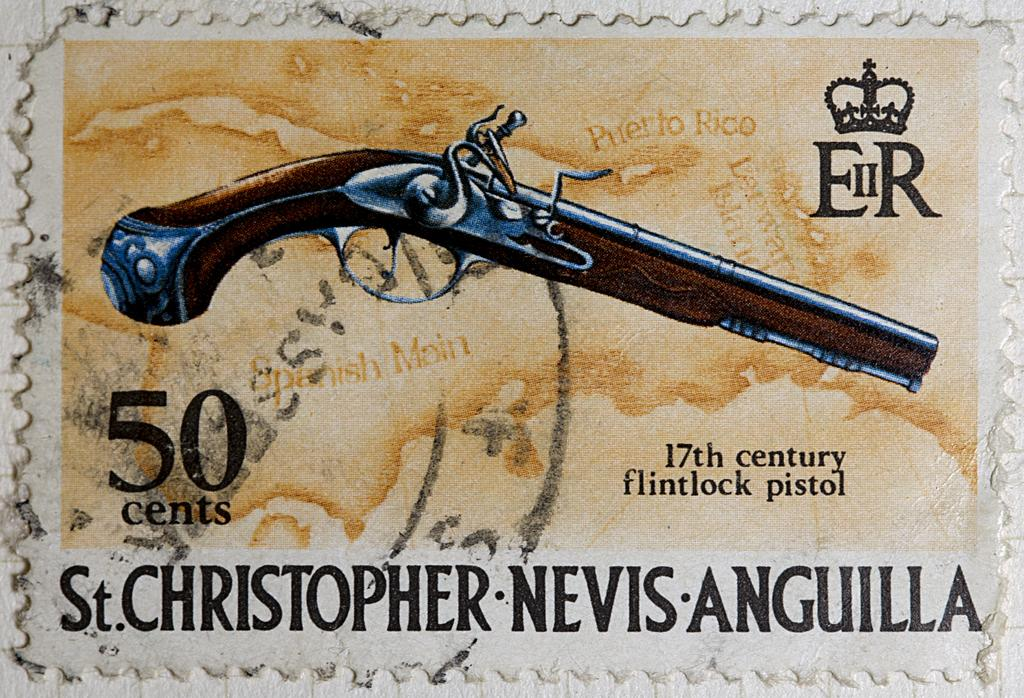What object is the main subject of the image? There is a pistol in the image. Can you describe the appearance of the pistol? The pistol resembles a stamp in the image. How many geese are flying in the image? There are no geese present in the image; it features a pistol that resembles a stamp. What type of bat is hanging from the pistol in the image? There is no bat present in the image; it only features a pistol that resembles a stamp. 